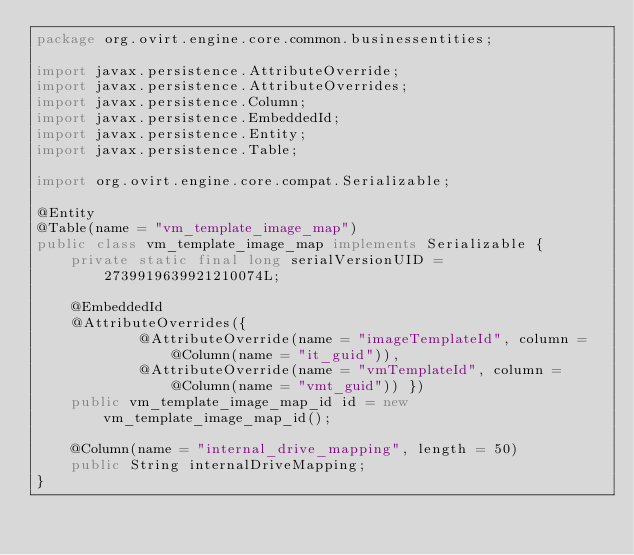<code> <loc_0><loc_0><loc_500><loc_500><_Java_>package org.ovirt.engine.core.common.businessentities;

import javax.persistence.AttributeOverride;
import javax.persistence.AttributeOverrides;
import javax.persistence.Column;
import javax.persistence.EmbeddedId;
import javax.persistence.Entity;
import javax.persistence.Table;

import org.ovirt.engine.core.compat.Serializable;

@Entity
@Table(name = "vm_template_image_map")
public class vm_template_image_map implements Serializable {
    private static final long serialVersionUID = 2739919639921210074L;

    @EmbeddedId
    @AttributeOverrides({
            @AttributeOverride(name = "imageTemplateId", column = @Column(name = "it_guid")),
            @AttributeOverride(name = "vmTemplateId", column = @Column(name = "vmt_guid")) })
    public vm_template_image_map_id id = new vm_template_image_map_id();

    @Column(name = "internal_drive_mapping", length = 50)
    public String internalDriveMapping;
}
</code> 